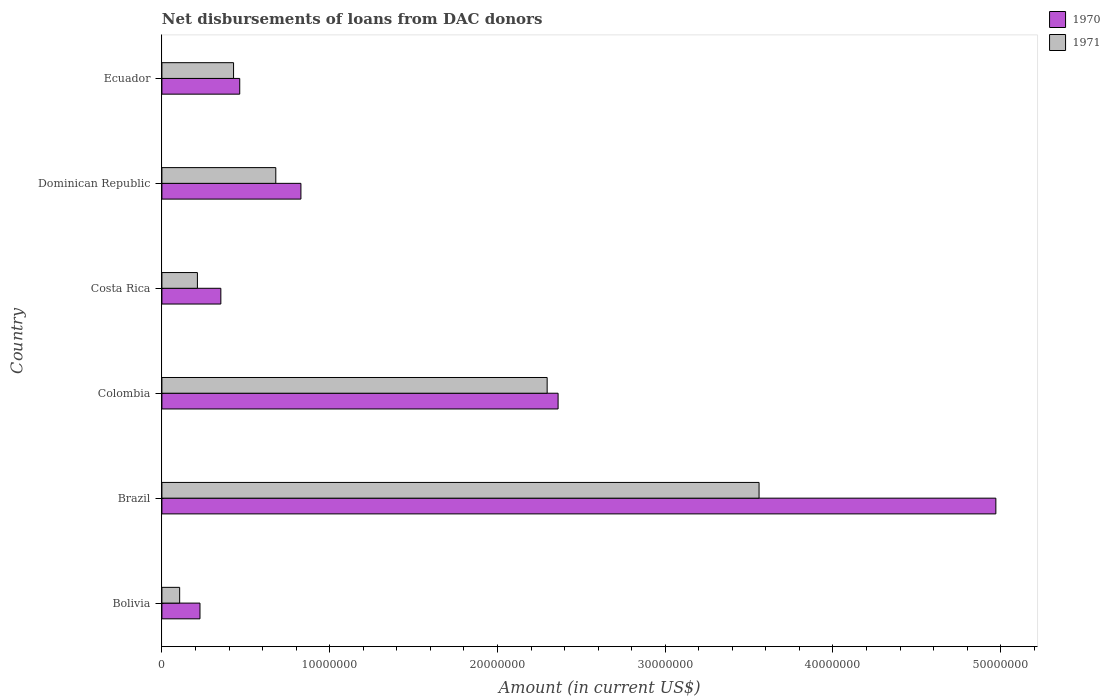How many different coloured bars are there?
Your answer should be compact. 2. Are the number of bars per tick equal to the number of legend labels?
Provide a short and direct response. Yes. Are the number of bars on each tick of the Y-axis equal?
Your answer should be very brief. Yes. How many bars are there on the 4th tick from the top?
Keep it short and to the point. 2. What is the label of the 1st group of bars from the top?
Provide a succinct answer. Ecuador. In how many cases, is the number of bars for a given country not equal to the number of legend labels?
Provide a short and direct response. 0. What is the amount of loans disbursed in 1971 in Dominican Republic?
Your answer should be very brief. 6.79e+06. Across all countries, what is the maximum amount of loans disbursed in 1970?
Offer a very short reply. 4.97e+07. Across all countries, what is the minimum amount of loans disbursed in 1971?
Your response must be concise. 1.06e+06. In which country was the amount of loans disbursed in 1970 maximum?
Provide a short and direct response. Brazil. In which country was the amount of loans disbursed in 1971 minimum?
Provide a short and direct response. Bolivia. What is the total amount of loans disbursed in 1970 in the graph?
Offer a very short reply. 9.20e+07. What is the difference between the amount of loans disbursed in 1971 in Dominican Republic and that in Ecuador?
Provide a short and direct response. 2.52e+06. What is the difference between the amount of loans disbursed in 1970 in Costa Rica and the amount of loans disbursed in 1971 in Colombia?
Keep it short and to the point. -1.94e+07. What is the average amount of loans disbursed in 1970 per country?
Ensure brevity in your answer.  1.53e+07. What is the difference between the amount of loans disbursed in 1970 and amount of loans disbursed in 1971 in Costa Rica?
Provide a succinct answer. 1.40e+06. In how many countries, is the amount of loans disbursed in 1970 greater than 18000000 US$?
Your answer should be compact. 2. What is the ratio of the amount of loans disbursed in 1971 in Bolivia to that in Colombia?
Offer a very short reply. 0.05. Is the amount of loans disbursed in 1970 in Brazil less than that in Costa Rica?
Your answer should be compact. No. What is the difference between the highest and the second highest amount of loans disbursed in 1970?
Give a very brief answer. 2.61e+07. What is the difference between the highest and the lowest amount of loans disbursed in 1970?
Keep it short and to the point. 4.74e+07. What does the 2nd bar from the top in Colombia represents?
Offer a terse response. 1970. What does the 2nd bar from the bottom in Costa Rica represents?
Your answer should be very brief. 1971. How many bars are there?
Provide a short and direct response. 12. Are all the bars in the graph horizontal?
Ensure brevity in your answer.  Yes. What is the difference between two consecutive major ticks on the X-axis?
Provide a short and direct response. 1.00e+07. Does the graph contain any zero values?
Provide a short and direct response. No. Does the graph contain grids?
Offer a very short reply. No. How many legend labels are there?
Ensure brevity in your answer.  2. How are the legend labels stacked?
Give a very brief answer. Vertical. What is the title of the graph?
Your answer should be compact. Net disbursements of loans from DAC donors. What is the label or title of the X-axis?
Ensure brevity in your answer.  Amount (in current US$). What is the Amount (in current US$) of 1970 in Bolivia?
Make the answer very short. 2.27e+06. What is the Amount (in current US$) of 1971 in Bolivia?
Provide a succinct answer. 1.06e+06. What is the Amount (in current US$) in 1970 in Brazil?
Your answer should be very brief. 4.97e+07. What is the Amount (in current US$) in 1971 in Brazil?
Provide a short and direct response. 3.56e+07. What is the Amount (in current US$) in 1970 in Colombia?
Ensure brevity in your answer.  2.36e+07. What is the Amount (in current US$) in 1971 in Colombia?
Ensure brevity in your answer.  2.30e+07. What is the Amount (in current US$) in 1970 in Costa Rica?
Keep it short and to the point. 3.51e+06. What is the Amount (in current US$) in 1971 in Costa Rica?
Your response must be concise. 2.12e+06. What is the Amount (in current US$) of 1970 in Dominican Republic?
Offer a terse response. 8.29e+06. What is the Amount (in current US$) in 1971 in Dominican Republic?
Offer a very short reply. 6.79e+06. What is the Amount (in current US$) of 1970 in Ecuador?
Ensure brevity in your answer.  4.64e+06. What is the Amount (in current US$) in 1971 in Ecuador?
Your response must be concise. 4.27e+06. Across all countries, what is the maximum Amount (in current US$) in 1970?
Make the answer very short. 4.97e+07. Across all countries, what is the maximum Amount (in current US$) in 1971?
Give a very brief answer. 3.56e+07. Across all countries, what is the minimum Amount (in current US$) in 1970?
Your response must be concise. 2.27e+06. Across all countries, what is the minimum Amount (in current US$) of 1971?
Keep it short and to the point. 1.06e+06. What is the total Amount (in current US$) of 1970 in the graph?
Your answer should be very brief. 9.20e+07. What is the total Amount (in current US$) of 1971 in the graph?
Your response must be concise. 7.28e+07. What is the difference between the Amount (in current US$) of 1970 in Bolivia and that in Brazil?
Your answer should be very brief. -4.74e+07. What is the difference between the Amount (in current US$) of 1971 in Bolivia and that in Brazil?
Offer a very short reply. -3.45e+07. What is the difference between the Amount (in current US$) of 1970 in Bolivia and that in Colombia?
Provide a short and direct response. -2.13e+07. What is the difference between the Amount (in current US$) of 1971 in Bolivia and that in Colombia?
Give a very brief answer. -2.19e+07. What is the difference between the Amount (in current US$) in 1970 in Bolivia and that in Costa Rica?
Your answer should be very brief. -1.24e+06. What is the difference between the Amount (in current US$) of 1971 in Bolivia and that in Costa Rica?
Give a very brief answer. -1.06e+06. What is the difference between the Amount (in current US$) of 1970 in Bolivia and that in Dominican Republic?
Your response must be concise. -6.02e+06. What is the difference between the Amount (in current US$) in 1971 in Bolivia and that in Dominican Republic?
Your answer should be very brief. -5.73e+06. What is the difference between the Amount (in current US$) in 1970 in Bolivia and that in Ecuador?
Make the answer very short. -2.37e+06. What is the difference between the Amount (in current US$) in 1971 in Bolivia and that in Ecuador?
Offer a very short reply. -3.21e+06. What is the difference between the Amount (in current US$) of 1970 in Brazil and that in Colombia?
Ensure brevity in your answer.  2.61e+07. What is the difference between the Amount (in current US$) of 1971 in Brazil and that in Colombia?
Provide a short and direct response. 1.26e+07. What is the difference between the Amount (in current US$) in 1970 in Brazil and that in Costa Rica?
Offer a very short reply. 4.62e+07. What is the difference between the Amount (in current US$) in 1971 in Brazil and that in Costa Rica?
Offer a very short reply. 3.35e+07. What is the difference between the Amount (in current US$) of 1970 in Brazil and that in Dominican Republic?
Offer a very short reply. 4.14e+07. What is the difference between the Amount (in current US$) in 1971 in Brazil and that in Dominican Republic?
Provide a short and direct response. 2.88e+07. What is the difference between the Amount (in current US$) of 1970 in Brazil and that in Ecuador?
Give a very brief answer. 4.51e+07. What is the difference between the Amount (in current US$) of 1971 in Brazil and that in Ecuador?
Ensure brevity in your answer.  3.13e+07. What is the difference between the Amount (in current US$) of 1970 in Colombia and that in Costa Rica?
Make the answer very short. 2.01e+07. What is the difference between the Amount (in current US$) in 1971 in Colombia and that in Costa Rica?
Offer a very short reply. 2.08e+07. What is the difference between the Amount (in current US$) of 1970 in Colombia and that in Dominican Republic?
Your response must be concise. 1.53e+07. What is the difference between the Amount (in current US$) of 1971 in Colombia and that in Dominican Republic?
Offer a very short reply. 1.62e+07. What is the difference between the Amount (in current US$) of 1970 in Colombia and that in Ecuador?
Offer a very short reply. 1.90e+07. What is the difference between the Amount (in current US$) in 1971 in Colombia and that in Ecuador?
Offer a very short reply. 1.87e+07. What is the difference between the Amount (in current US$) of 1970 in Costa Rica and that in Dominican Republic?
Ensure brevity in your answer.  -4.77e+06. What is the difference between the Amount (in current US$) of 1971 in Costa Rica and that in Dominican Republic?
Your answer should be very brief. -4.67e+06. What is the difference between the Amount (in current US$) in 1970 in Costa Rica and that in Ecuador?
Keep it short and to the point. -1.13e+06. What is the difference between the Amount (in current US$) in 1971 in Costa Rica and that in Ecuador?
Give a very brief answer. -2.16e+06. What is the difference between the Amount (in current US$) of 1970 in Dominican Republic and that in Ecuador?
Provide a short and direct response. 3.65e+06. What is the difference between the Amount (in current US$) of 1971 in Dominican Republic and that in Ecuador?
Your response must be concise. 2.52e+06. What is the difference between the Amount (in current US$) in 1970 in Bolivia and the Amount (in current US$) in 1971 in Brazil?
Provide a short and direct response. -3.33e+07. What is the difference between the Amount (in current US$) of 1970 in Bolivia and the Amount (in current US$) of 1971 in Colombia?
Your response must be concise. -2.07e+07. What is the difference between the Amount (in current US$) in 1970 in Bolivia and the Amount (in current US$) in 1971 in Costa Rica?
Ensure brevity in your answer.  1.54e+05. What is the difference between the Amount (in current US$) of 1970 in Bolivia and the Amount (in current US$) of 1971 in Dominican Republic?
Provide a short and direct response. -4.52e+06. What is the difference between the Amount (in current US$) of 1970 in Bolivia and the Amount (in current US$) of 1971 in Ecuador?
Make the answer very short. -2.00e+06. What is the difference between the Amount (in current US$) of 1970 in Brazil and the Amount (in current US$) of 1971 in Colombia?
Your answer should be very brief. 2.67e+07. What is the difference between the Amount (in current US$) of 1970 in Brazil and the Amount (in current US$) of 1971 in Costa Rica?
Offer a very short reply. 4.76e+07. What is the difference between the Amount (in current US$) of 1970 in Brazil and the Amount (in current US$) of 1971 in Dominican Republic?
Keep it short and to the point. 4.29e+07. What is the difference between the Amount (in current US$) of 1970 in Brazil and the Amount (in current US$) of 1971 in Ecuador?
Your answer should be very brief. 4.54e+07. What is the difference between the Amount (in current US$) in 1970 in Colombia and the Amount (in current US$) in 1971 in Costa Rica?
Ensure brevity in your answer.  2.15e+07. What is the difference between the Amount (in current US$) in 1970 in Colombia and the Amount (in current US$) in 1971 in Dominican Republic?
Offer a very short reply. 1.68e+07. What is the difference between the Amount (in current US$) of 1970 in Colombia and the Amount (in current US$) of 1971 in Ecuador?
Provide a succinct answer. 1.93e+07. What is the difference between the Amount (in current US$) of 1970 in Costa Rica and the Amount (in current US$) of 1971 in Dominican Republic?
Offer a terse response. -3.28e+06. What is the difference between the Amount (in current US$) of 1970 in Costa Rica and the Amount (in current US$) of 1971 in Ecuador?
Ensure brevity in your answer.  -7.58e+05. What is the difference between the Amount (in current US$) of 1970 in Dominican Republic and the Amount (in current US$) of 1971 in Ecuador?
Give a very brief answer. 4.02e+06. What is the average Amount (in current US$) in 1970 per country?
Make the answer very short. 1.53e+07. What is the average Amount (in current US$) of 1971 per country?
Your response must be concise. 1.21e+07. What is the difference between the Amount (in current US$) in 1970 and Amount (in current US$) in 1971 in Bolivia?
Your answer should be very brief. 1.21e+06. What is the difference between the Amount (in current US$) of 1970 and Amount (in current US$) of 1971 in Brazil?
Your response must be concise. 1.41e+07. What is the difference between the Amount (in current US$) of 1970 and Amount (in current US$) of 1971 in Colombia?
Provide a short and direct response. 6.52e+05. What is the difference between the Amount (in current US$) in 1970 and Amount (in current US$) in 1971 in Costa Rica?
Provide a succinct answer. 1.40e+06. What is the difference between the Amount (in current US$) in 1970 and Amount (in current US$) in 1971 in Dominican Republic?
Provide a succinct answer. 1.50e+06. What is the difference between the Amount (in current US$) of 1970 and Amount (in current US$) of 1971 in Ecuador?
Your response must be concise. 3.68e+05. What is the ratio of the Amount (in current US$) in 1970 in Bolivia to that in Brazil?
Keep it short and to the point. 0.05. What is the ratio of the Amount (in current US$) in 1971 in Bolivia to that in Brazil?
Provide a succinct answer. 0.03. What is the ratio of the Amount (in current US$) in 1970 in Bolivia to that in Colombia?
Provide a short and direct response. 0.1. What is the ratio of the Amount (in current US$) of 1971 in Bolivia to that in Colombia?
Ensure brevity in your answer.  0.05. What is the ratio of the Amount (in current US$) in 1970 in Bolivia to that in Costa Rica?
Your response must be concise. 0.65. What is the ratio of the Amount (in current US$) of 1971 in Bolivia to that in Costa Rica?
Your answer should be very brief. 0.5. What is the ratio of the Amount (in current US$) of 1970 in Bolivia to that in Dominican Republic?
Your answer should be very brief. 0.27. What is the ratio of the Amount (in current US$) of 1971 in Bolivia to that in Dominican Republic?
Your response must be concise. 0.16. What is the ratio of the Amount (in current US$) of 1970 in Bolivia to that in Ecuador?
Provide a short and direct response. 0.49. What is the ratio of the Amount (in current US$) in 1971 in Bolivia to that in Ecuador?
Make the answer very short. 0.25. What is the ratio of the Amount (in current US$) in 1970 in Brazil to that in Colombia?
Provide a short and direct response. 2.1. What is the ratio of the Amount (in current US$) of 1971 in Brazil to that in Colombia?
Give a very brief answer. 1.55. What is the ratio of the Amount (in current US$) in 1970 in Brazil to that in Costa Rica?
Your answer should be very brief. 14.15. What is the ratio of the Amount (in current US$) in 1971 in Brazil to that in Costa Rica?
Your answer should be very brief. 16.82. What is the ratio of the Amount (in current US$) of 1970 in Brazil to that in Dominican Republic?
Your answer should be very brief. 6. What is the ratio of the Amount (in current US$) of 1971 in Brazil to that in Dominican Republic?
Give a very brief answer. 5.24. What is the ratio of the Amount (in current US$) of 1970 in Brazil to that in Ecuador?
Your answer should be very brief. 10.72. What is the ratio of the Amount (in current US$) in 1971 in Brazil to that in Ecuador?
Keep it short and to the point. 8.33. What is the ratio of the Amount (in current US$) in 1970 in Colombia to that in Costa Rica?
Your answer should be very brief. 6.72. What is the ratio of the Amount (in current US$) in 1971 in Colombia to that in Costa Rica?
Provide a short and direct response. 10.85. What is the ratio of the Amount (in current US$) of 1970 in Colombia to that in Dominican Republic?
Give a very brief answer. 2.85. What is the ratio of the Amount (in current US$) of 1971 in Colombia to that in Dominican Republic?
Your response must be concise. 3.38. What is the ratio of the Amount (in current US$) of 1970 in Colombia to that in Ecuador?
Make the answer very short. 5.09. What is the ratio of the Amount (in current US$) in 1971 in Colombia to that in Ecuador?
Make the answer very short. 5.38. What is the ratio of the Amount (in current US$) in 1970 in Costa Rica to that in Dominican Republic?
Ensure brevity in your answer.  0.42. What is the ratio of the Amount (in current US$) of 1971 in Costa Rica to that in Dominican Republic?
Make the answer very short. 0.31. What is the ratio of the Amount (in current US$) in 1970 in Costa Rica to that in Ecuador?
Your response must be concise. 0.76. What is the ratio of the Amount (in current US$) in 1971 in Costa Rica to that in Ecuador?
Offer a very short reply. 0.5. What is the ratio of the Amount (in current US$) in 1970 in Dominican Republic to that in Ecuador?
Offer a terse response. 1.79. What is the ratio of the Amount (in current US$) of 1971 in Dominican Republic to that in Ecuador?
Your answer should be compact. 1.59. What is the difference between the highest and the second highest Amount (in current US$) in 1970?
Your answer should be compact. 2.61e+07. What is the difference between the highest and the second highest Amount (in current US$) in 1971?
Provide a succinct answer. 1.26e+07. What is the difference between the highest and the lowest Amount (in current US$) of 1970?
Offer a very short reply. 4.74e+07. What is the difference between the highest and the lowest Amount (in current US$) of 1971?
Your response must be concise. 3.45e+07. 